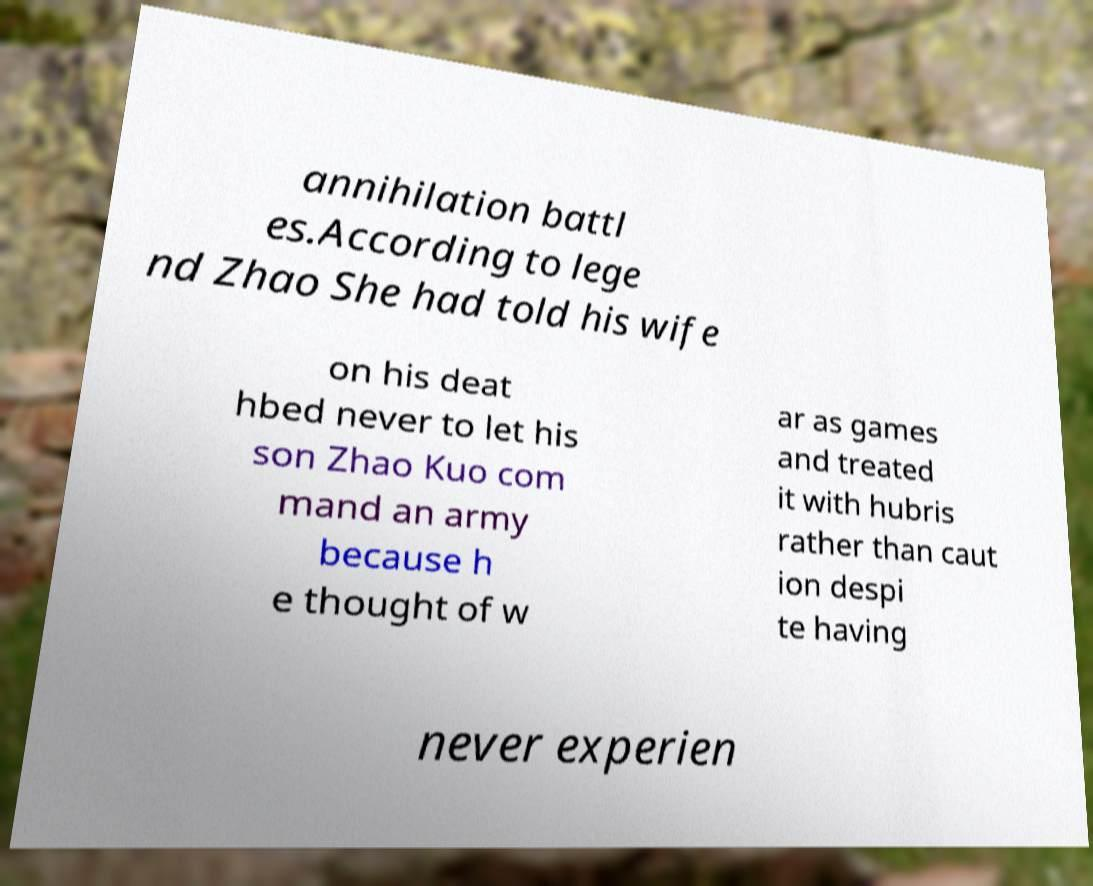There's text embedded in this image that I need extracted. Can you transcribe it verbatim? annihilation battl es.According to lege nd Zhao She had told his wife on his deat hbed never to let his son Zhao Kuo com mand an army because h e thought of w ar as games and treated it with hubris rather than caut ion despi te having never experien 